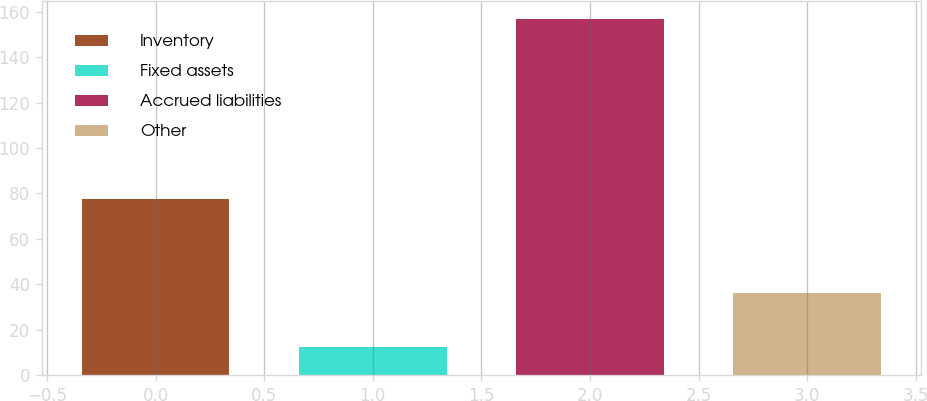Convert chart. <chart><loc_0><loc_0><loc_500><loc_500><bar_chart><fcel>Inventory<fcel>Fixed assets<fcel>Accrued liabilities<fcel>Other<nl><fcel>77.6<fcel>12.3<fcel>156.9<fcel>36.1<nl></chart> 